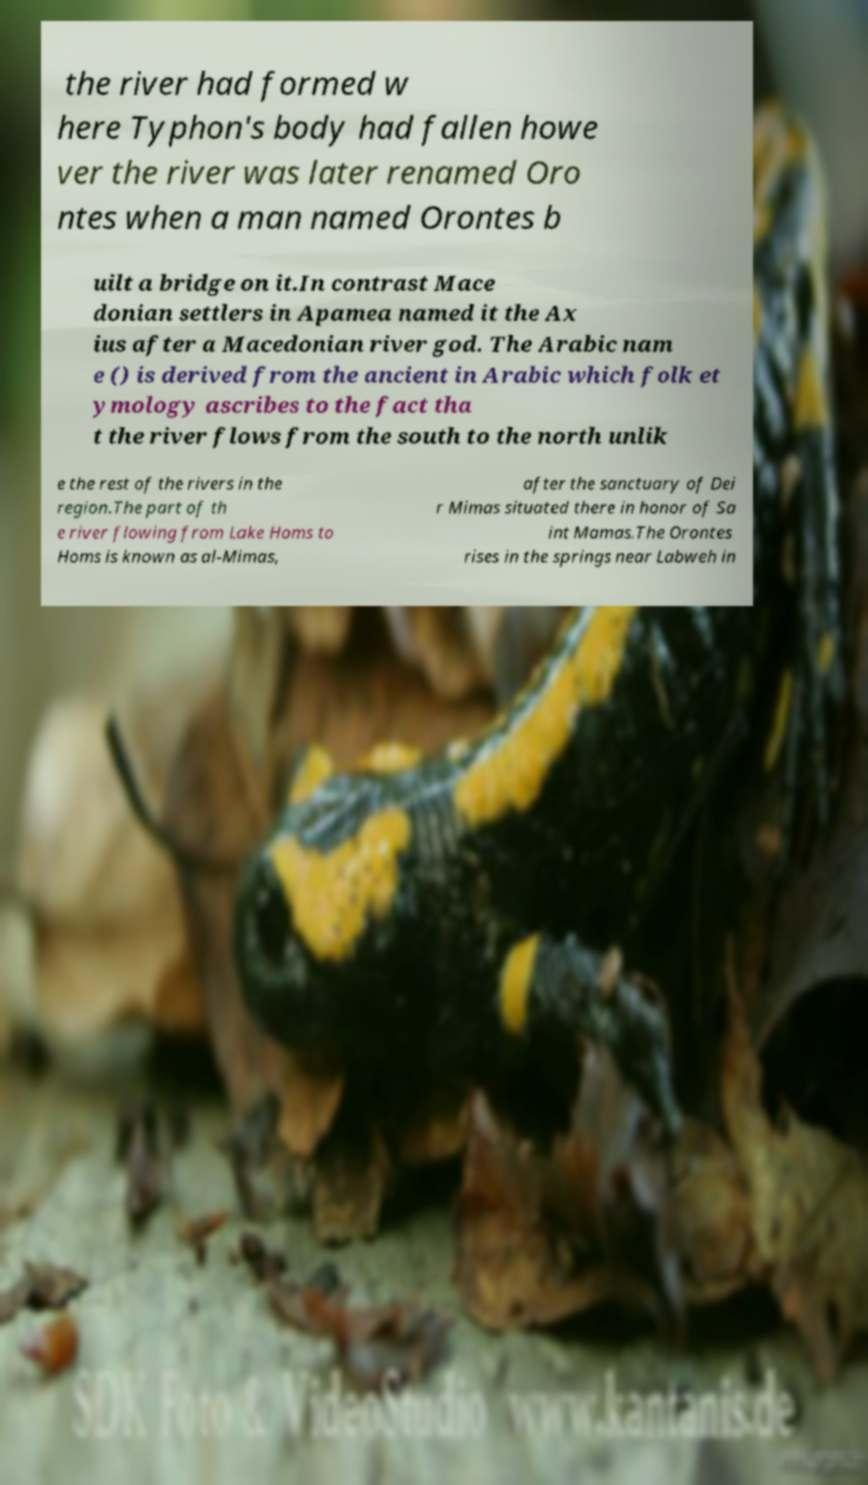Can you accurately transcribe the text from the provided image for me? the river had formed w here Typhon's body had fallen howe ver the river was later renamed Oro ntes when a man named Orontes b uilt a bridge on it.In contrast Mace donian settlers in Apamea named it the Ax ius after a Macedonian river god. The Arabic nam e () is derived from the ancient in Arabic which folk et ymology ascribes to the fact tha t the river flows from the south to the north unlik e the rest of the rivers in the region.The part of th e river flowing from Lake Homs to Homs is known as al-Mimas, after the sanctuary of Dei r Mimas situated there in honor of Sa int Mamas.The Orontes rises in the springs near Labweh in 